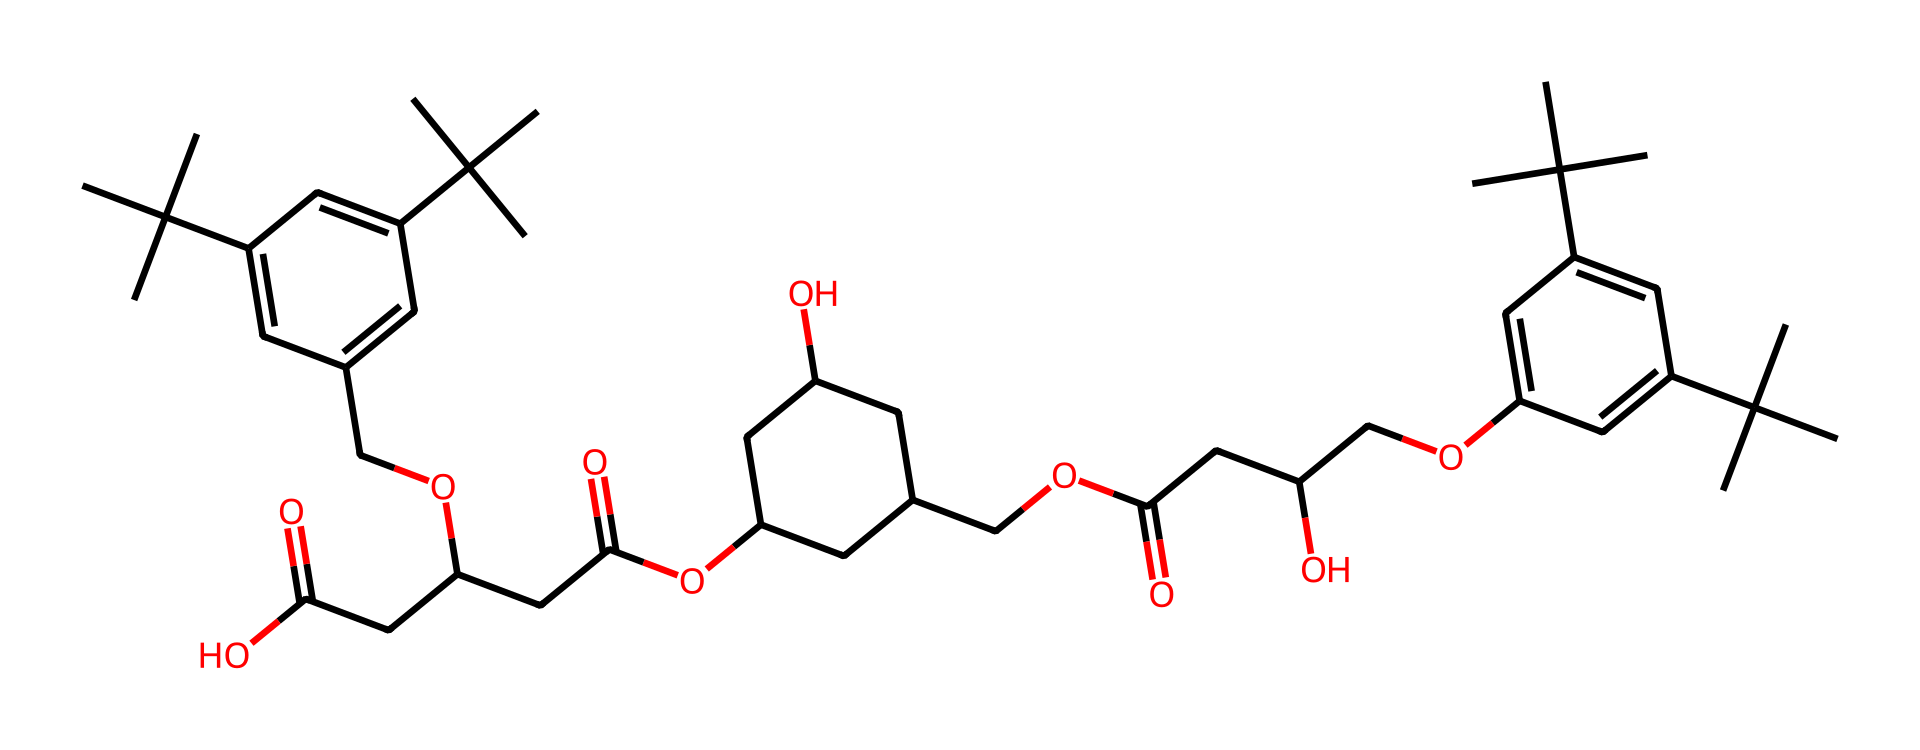What type of functional group is present in this compound? The chemical structure contains multiple instances of ester linkages, which are characterized by the presence of carbonyl (C=O) adjacent to an ether bond (-O-). This indicates the presence of esters, which are typical in alkyd resins.
Answer: ester How many carbon atoms are present in the compound? By analyzing the SMILES representation, we can count the total number of carbon atoms. Each "C" represents a carbon atom. After counting each individual carbon present in the entire structure, we find that there are 31 carbon atoms in total.
Answer: 31 What is the primary purpose of alkyd resins in oil-based inks? Alkyd resins are primarily used as binding agents in oil-based inks, contributing to film formation and enhancing the gloss and durability of prints. This is crucial for fine art landscape prints, where appearance matters significantly.
Answer: binding agents What type of polymerization process is involved in making alkyd resins? Alkyd resins are typically produced through a polycondensation reaction, which involves the reaction of polyols and polybasic acids. This process leads to the formation of long-chain polymers that give alkyd resins their desirable properties.
Answer: polycondensation How many functional groups are noted in the alkyd resin structure? In the provided chemical structure, we can identify the presence of multiple functional groups, including ester and hydroxyl groups. Upon evaluation, it is clear that there are two primary functional groups present in this structure: esters and alcohols.
Answer: two 